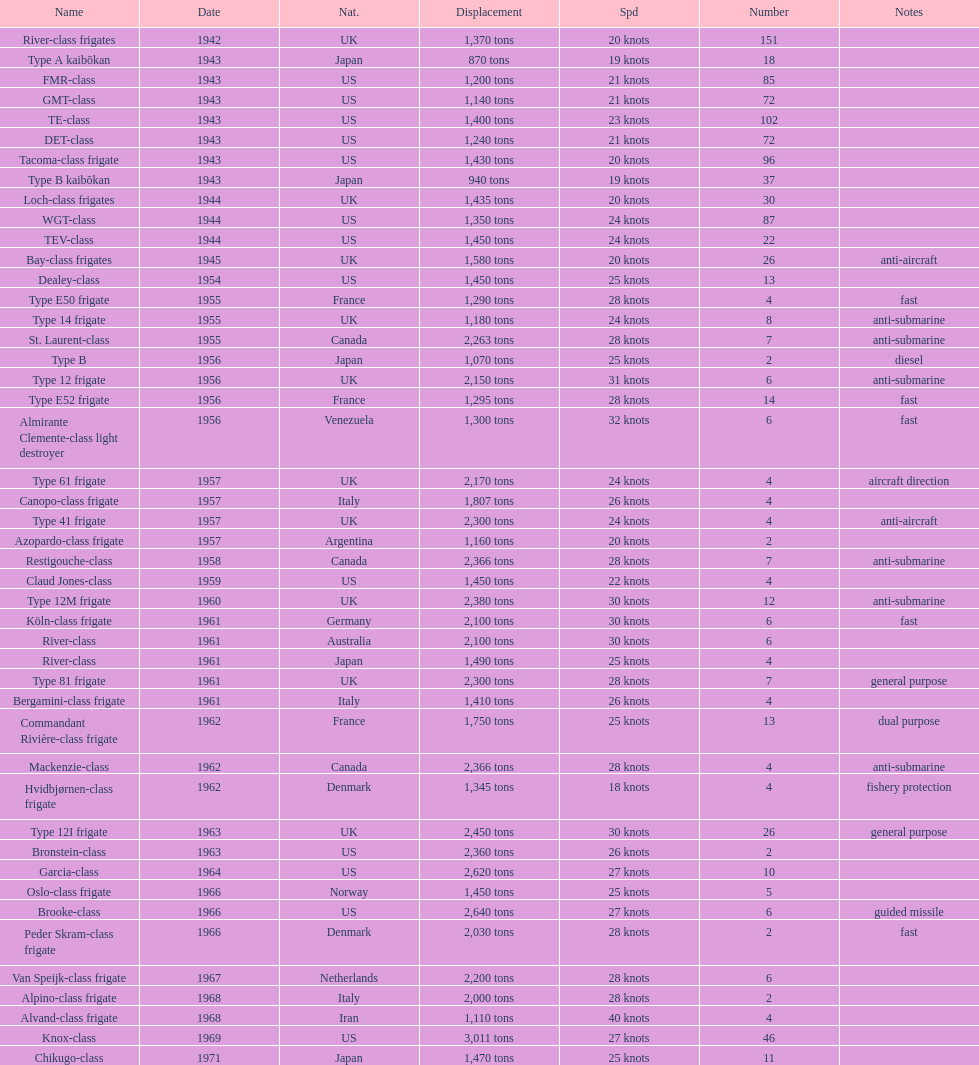What is the displacement in tons for type b? 940 tons. 